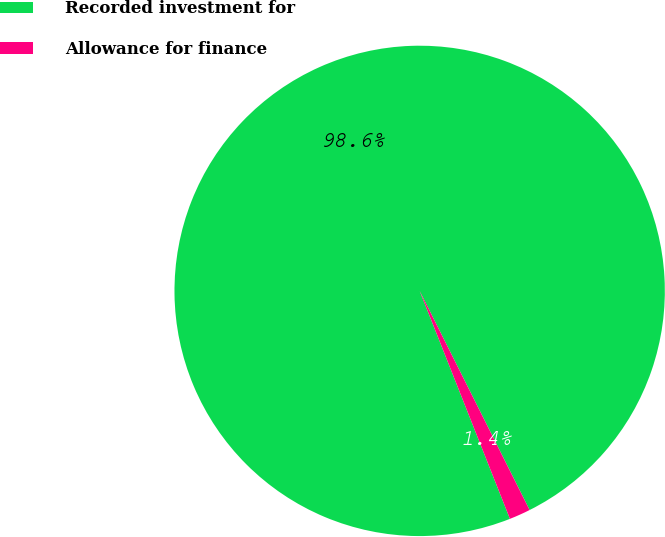<chart> <loc_0><loc_0><loc_500><loc_500><pie_chart><fcel>Recorded investment for<fcel>Allowance for finance<nl><fcel>98.6%<fcel>1.4%<nl></chart> 